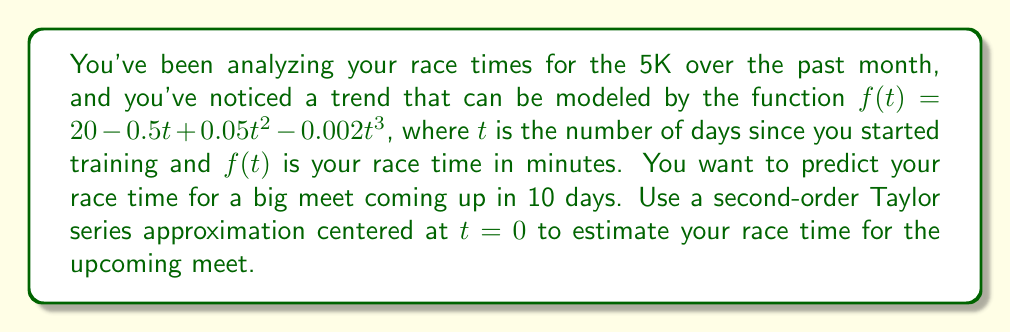What is the answer to this math problem? To solve this problem, we'll use a second-order Taylor series approximation of the function $f(t)$ centered at $t=0$. The general form of a second-order Taylor series is:

$$f(t) \approx f(0) + f'(0)t + \frac{f''(0)}{2!}t^2$$

Let's find each component:

1) $f(0) = 20 - 0.5(0) + 0.05(0)^2 - 0.002(0)^3 = 20$

2) $f'(t) = -0.5 + 0.1t - 0.006t^2$
   $f'(0) = -0.5$

3) $f''(t) = 0.1 - 0.012t$
   $f''(0) = 0.1$

Now, let's substitute these values into our Taylor series approximation:

$$f(t) \approx 20 + (-0.5)t + \frac{0.1}{2}t^2$$

Simplifying:

$$f(t) \approx 20 - 0.5t + 0.05t^2$$

To predict the race time in 10 days, we substitute $t=10$:

$$f(10) \approx 20 - 0.5(10) + 0.05(10)^2$$
$$f(10) \approx 20 - 5 + 5$$
$$f(10) \approx 20$$

Therefore, the estimated race time for the meet in 10 days is approximately 20 minutes.
Answer: 20 minutes 